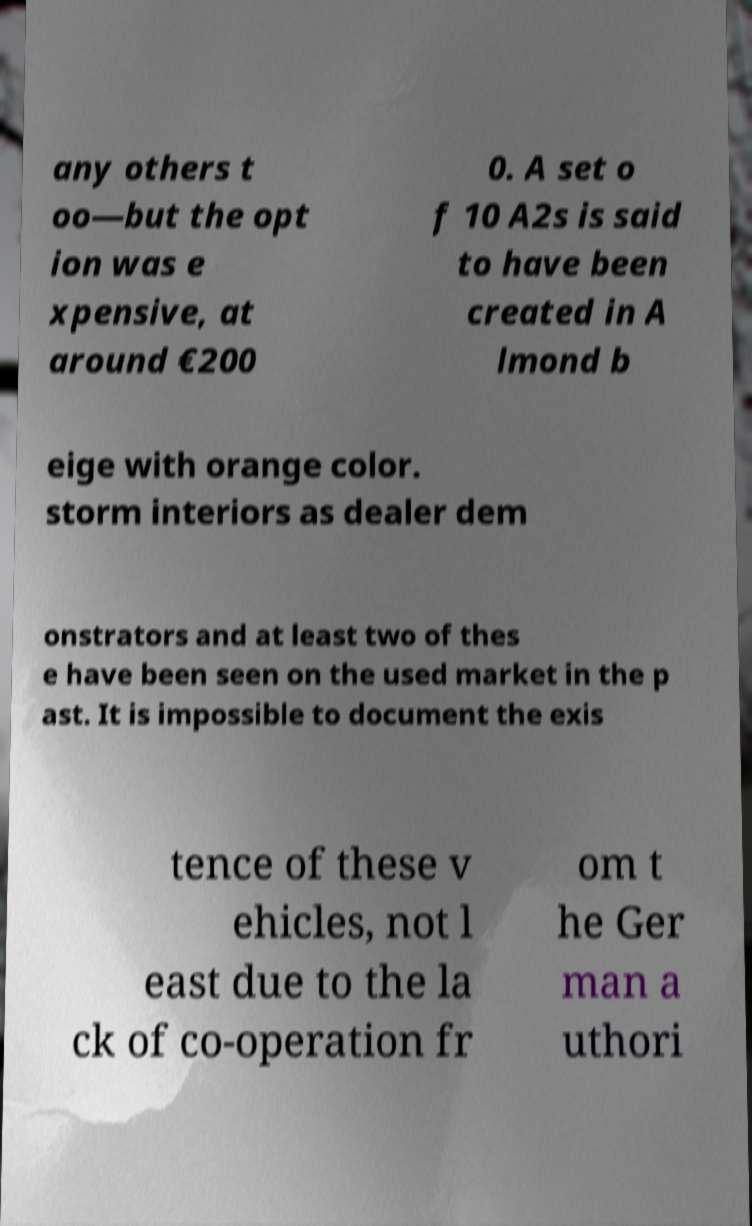Please read and relay the text visible in this image. What does it say? any others t oo—but the opt ion was e xpensive, at around €200 0. A set o f 10 A2s is said to have been created in A lmond b eige with orange color. storm interiors as dealer dem onstrators and at least two of thes e have been seen on the used market in the p ast. It is impossible to document the exis tence of these v ehicles, not l east due to the la ck of co-operation fr om t he Ger man a uthori 